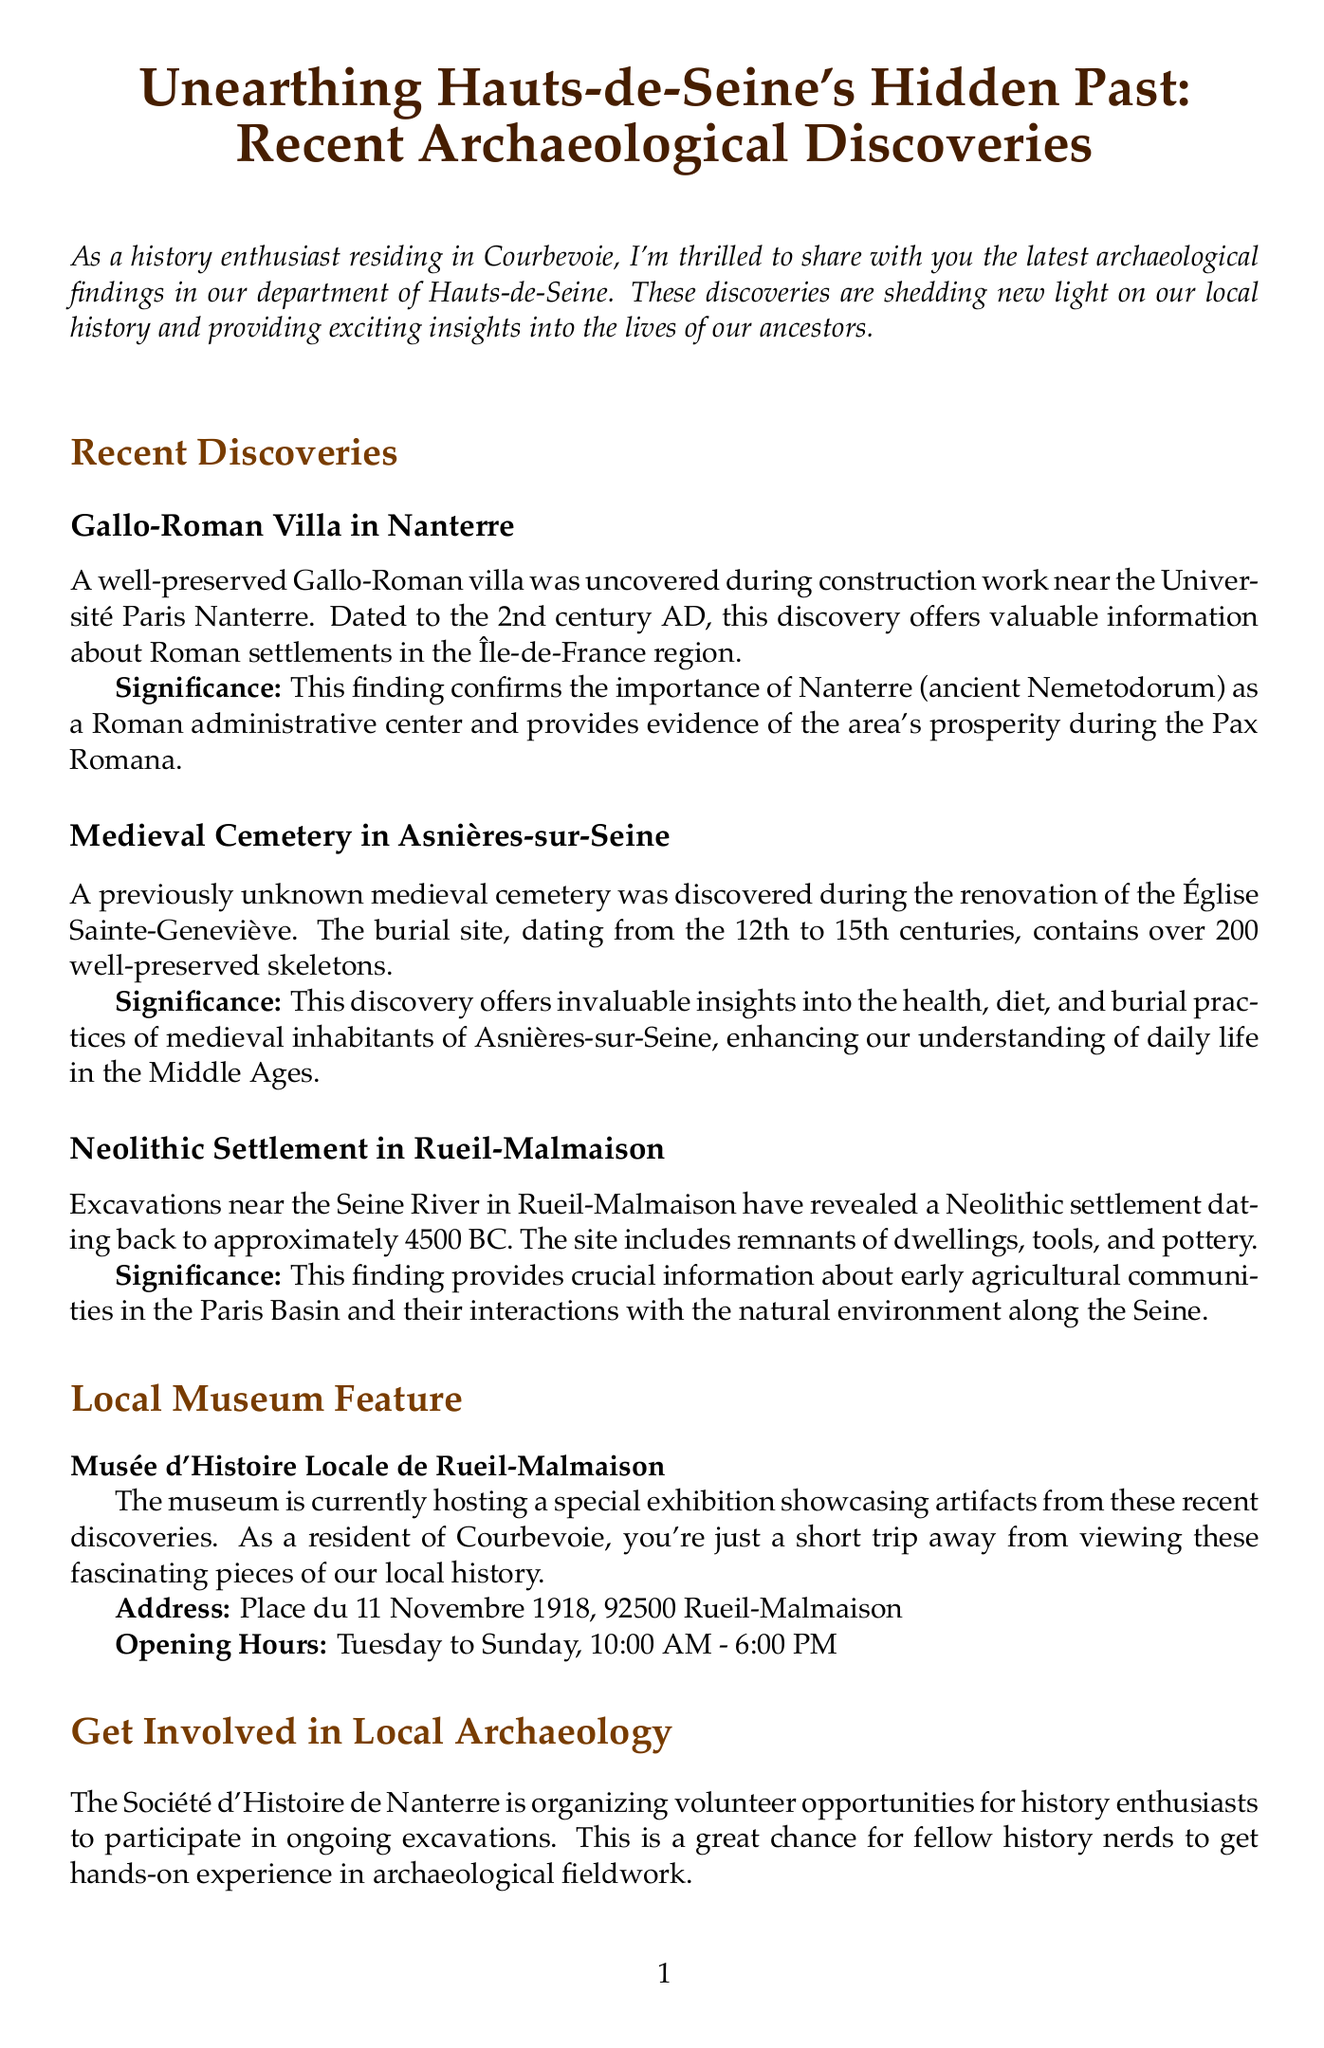What is the title of the newsletter? The title of the newsletter is provided at the beginning of the document, which is "Unearthing Hauts-de-Seine's Hidden Past: Recent Archaeological Discoveries."
Answer: Unearthing Hauts-de-Seine's Hidden Past: Recent Archaeological Discoveries What century is the Gallo-Roman villa from? The Gallo-Roman villa is dated to the 2nd century AD, as mentioned in the discovery section.
Answer: 2nd century AD How many skeletons were found in the medieval cemetery? The document states that the medieval cemetery contains over 200 well-preserved skeletons.
Answer: Over 200 What is the significance of the Neolithic settlement? The significance of the Neolithic settlement is provided in the description, stating it gives information about early agricultural communities in the Paris Basin.
Answer: Early agricultural communities What local museum is showcasing artifacts from the discoveries? The local museum featured in the document is named "Musée d'Histoire Locale de Rueil-Malmaison."
Answer: Musée d'Histoire Locale de Rueil-Malmaison What is the address of the local museum? The document provides the address of the museum as Place du 11 Novembre 1918, 92500 Rueil-Malmaison.
Answer: Place du 11 Novembre 1918, 92500 Rueil-Malmaison What organization is offering volunteer opportunities for history enthusiasts? The document mentions the "Société d'Histoire de Nanterre" as the organization providing volunteer opportunities.
Answer: Société d'Histoire de Nanterre On which days is the local museum open? The opening days of the museum are specified in the document as Tuesday to Sunday.
Answer: Tuesday to Sunday 